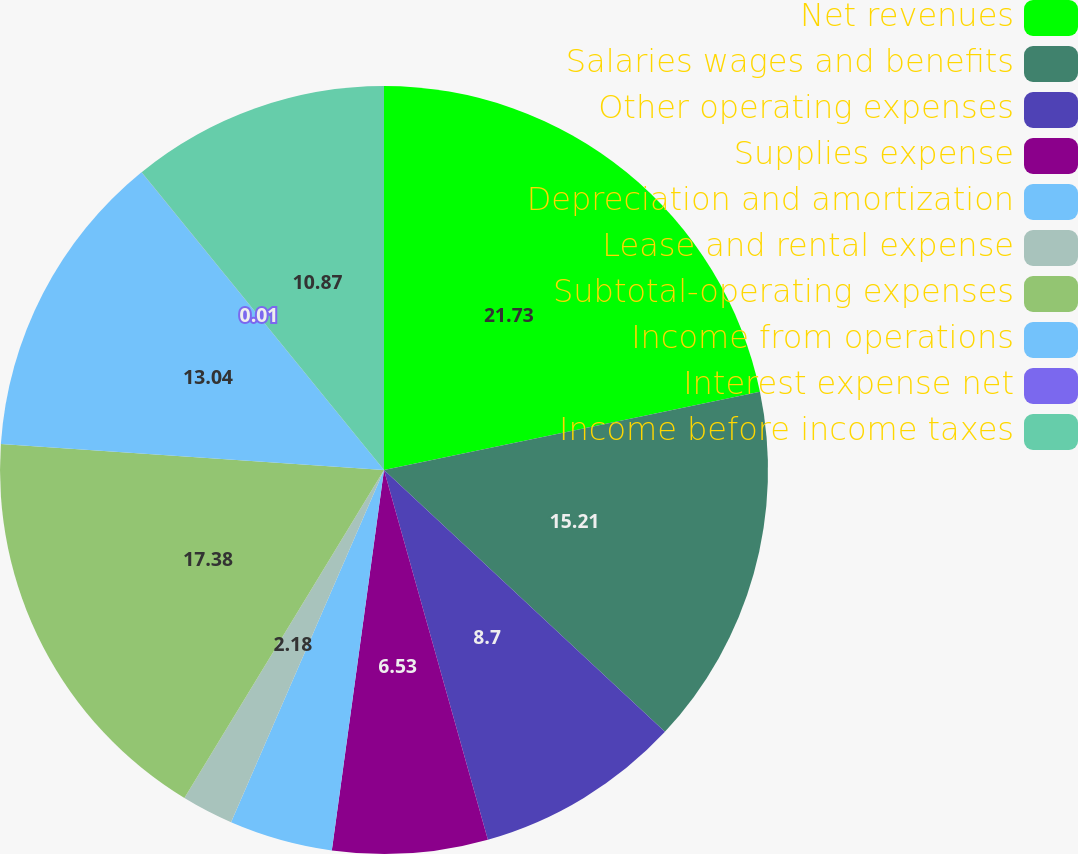<chart> <loc_0><loc_0><loc_500><loc_500><pie_chart><fcel>Net revenues<fcel>Salaries wages and benefits<fcel>Other operating expenses<fcel>Supplies expense<fcel>Depreciation and amortization<fcel>Lease and rental expense<fcel>Subtotal-operating expenses<fcel>Income from operations<fcel>Interest expense net<fcel>Income before income taxes<nl><fcel>21.73%<fcel>15.21%<fcel>8.7%<fcel>6.53%<fcel>4.35%<fcel>2.18%<fcel>17.38%<fcel>13.04%<fcel>0.01%<fcel>10.87%<nl></chart> 